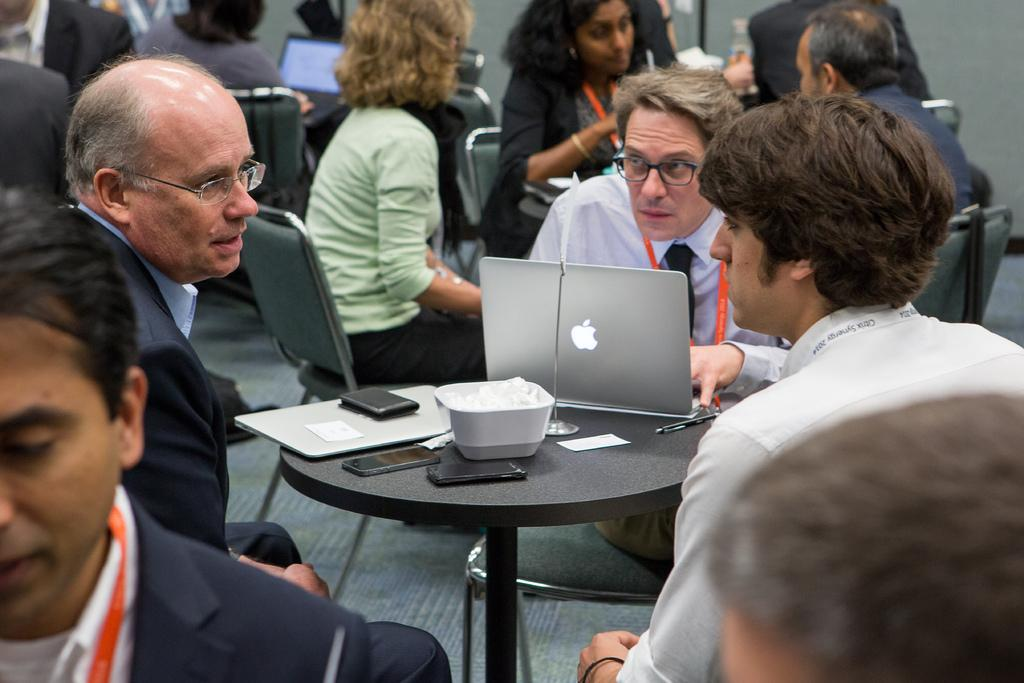What are the people in the image doing? People are sitting in groups at tables. How many men are sitting at one table? Three men are sitting at a table. What electronic devices can be seen on the table? There is a laptop and two mobile phones on the table. What type of document is on the table? There is a file on the table. What type of news can be seen on the banana in the image? There is no banana present in the image, and therefore no news can be seen on it. What type of polish is being used on the table in the image? There is no indication of any polish being used on the table in the image. 